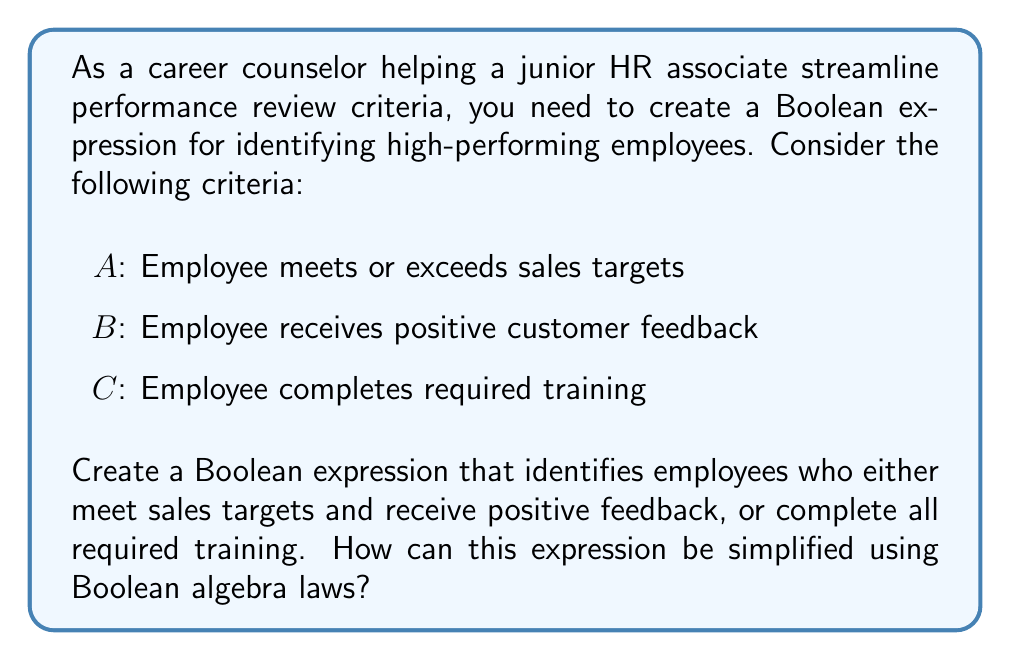Give your solution to this math problem. Let's approach this step-by-step:

1) First, let's write out the Boolean expression based on the given criteria:

   $$(A \cdot B) + C$$

   This expression means (A AND B) OR C, which satisfies the conditions stated in the question.

2) To simplify this expression, we can use the distributive law of Boolean algebra. The distributive law states that:

   $$X + (Y \cdot Z) = (X + Y) \cdot (X + Z)$$

3) In our case, we can apply the distributive law in reverse. Let's distribute C over A and B:

   $$(A \cdot B) + C = (A + C) \cdot (B + C)$$

4) This simplified form is logically equivalent to our original expression but may be more efficient in terms of evaluation.

5) To verify, we can create a truth table for both expressions and confirm they produce the same results for all possible input combinations.

6) This simplified form can be interpreted as: An employee is high-performing if they either meet sales targets or complete training, AND they either receive positive feedback or complete training.

This Boolean expression can help the junior HR associate more efficiently evaluate employee performance by reducing the number of logical operations required.
Answer: $$(A + C) \cdot (B + C)$$ 